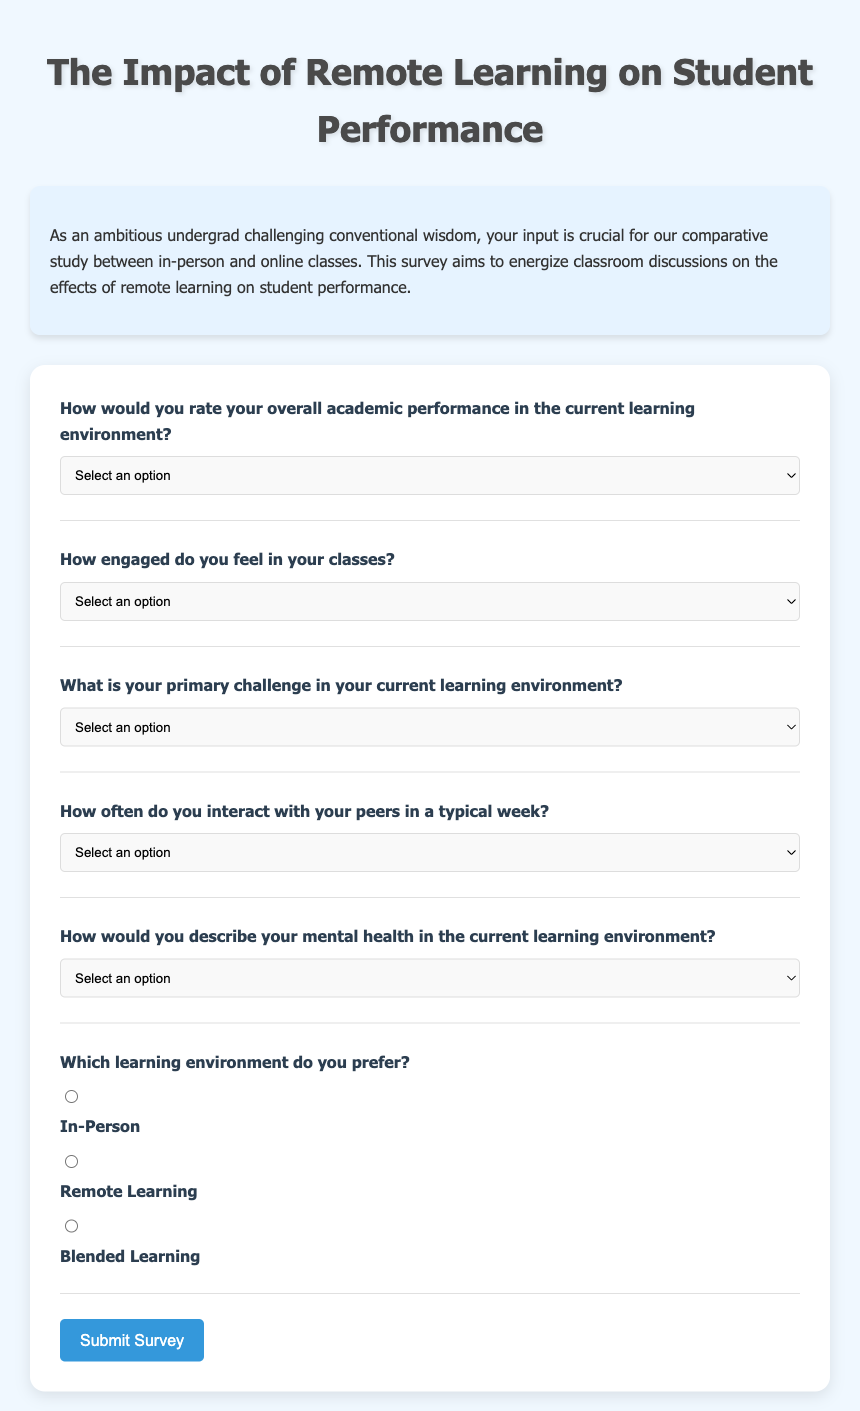What is the title of the survey? The title of the survey is prominently displayed at the top of the document, which is "The Impact of Remote Learning on Student Performance."
Answer: The Impact of Remote Learning on Student Performance How many primary challenges can respondents choose from in the survey? There are five options available for respondents to select their primary challenge, as listed in the options provided.
Answer: Five What is the background color of the body in the document? The background color for the body section is specified in the CSS style of the document, which is a light blue color.
Answer: Light blue Which learning environment does the survey ask about in terms of preference? The survey includes a section dedicated to learning environment preferences, specifically about three distinct options.
Answer: In-Person, Remote Learning, Blended Learning How many types of engagement levels can respondents choose from? The survey presents five distinct options for engagement levels that respondents can select.
Answer: Five What is the maximum width of the body content in the survey? The maximum width is specified in the CSS styles within the document for readability and layout purposes.
Answer: 800 pixels How is the survey's introduction section styled? The introduction section has a specific styling with a light blue background, padding, and rounded corners to make it appealing.
Answer: Light blue background with padding and rounded corners In the survey, which option represents a very engaged state? The response options include specific terms for different engagement levels, with "Very Engaged" as one of the choices.
Answer: Very Engaged 